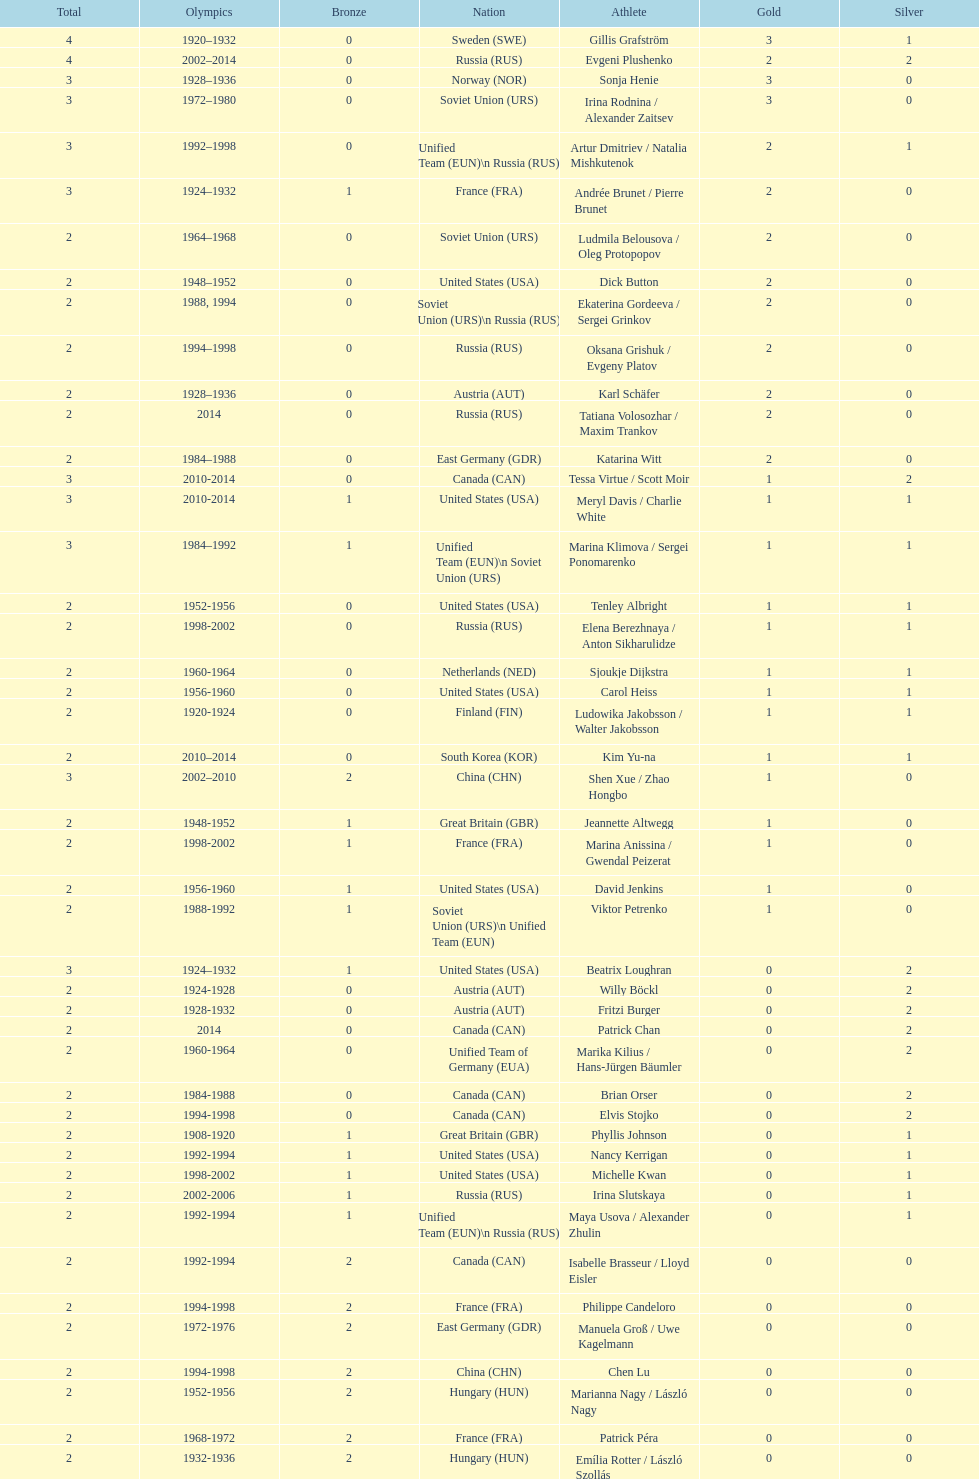What was the greatest number of gold medals won by a single athlete? 3. 